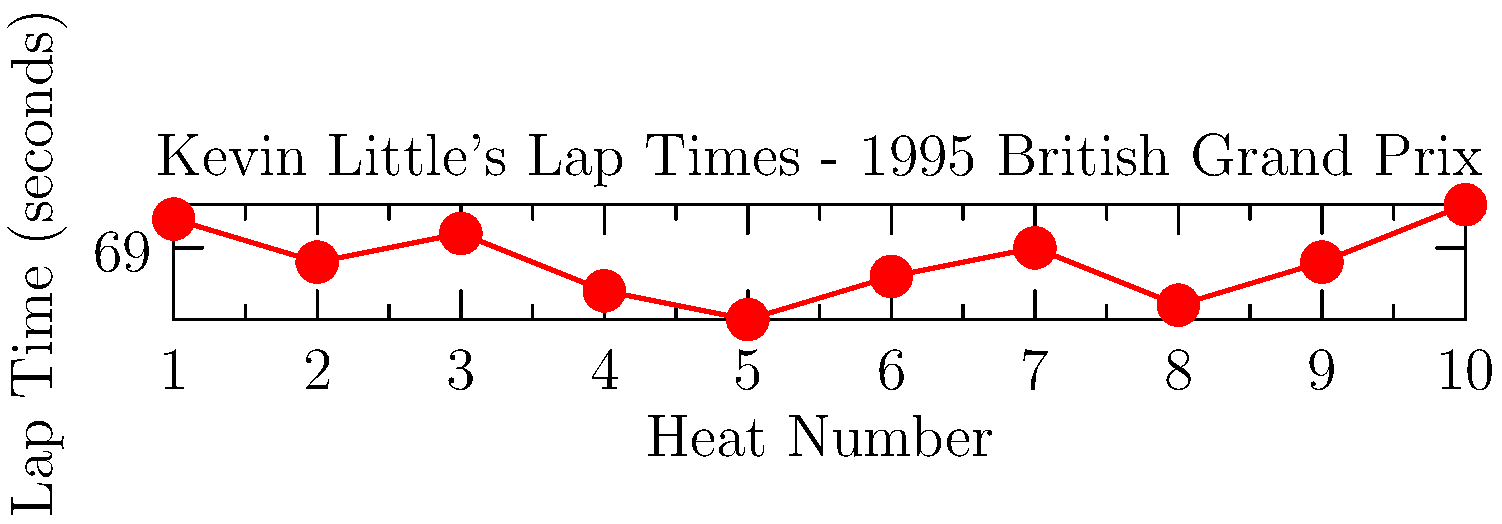Based on the graph showing Kevin Little's lap times during the 1995 British Grand Prix, which heat did he record his fastest lap time, and what was that time? To answer this question, we need to analyze the graph of Kevin Little's lap times:

1. The x-axis represents the heat number, from 1 to 10.
2. The y-axis represents the lap time in seconds.
3. We need to find the lowest point on the graph, which represents the fastest lap time.

Examining the graph:
- Heat 1: 69.2 seconds
- Heat 2: 68.9 seconds
- Heat 3: 69.1 seconds
- Heat 4: 68.7 seconds
- Heat 5: 68.5 seconds
- Heat 6: 68.8 seconds
- Heat 7: 69.0 seconds
- Heat 8: 68.6 seconds
- Heat 9: 68.9 seconds
- Heat 10: 69.3 seconds

The lowest point on the graph corresponds to Heat 5, with a lap time of 68.5 seconds.

Therefore, Kevin Little recorded his fastest lap time in Heat 5, which was 68.5 seconds.
Answer: Heat 5, 68.5 seconds 